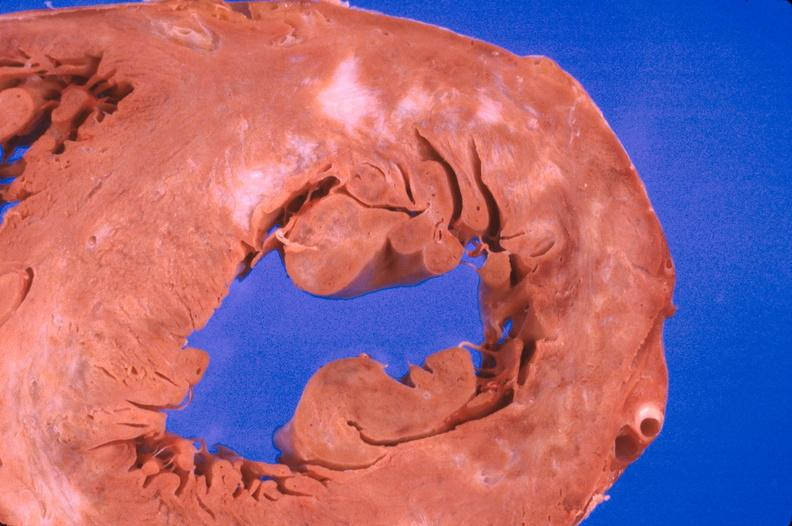where is this?
Answer the question using a single word or phrase. Heart 